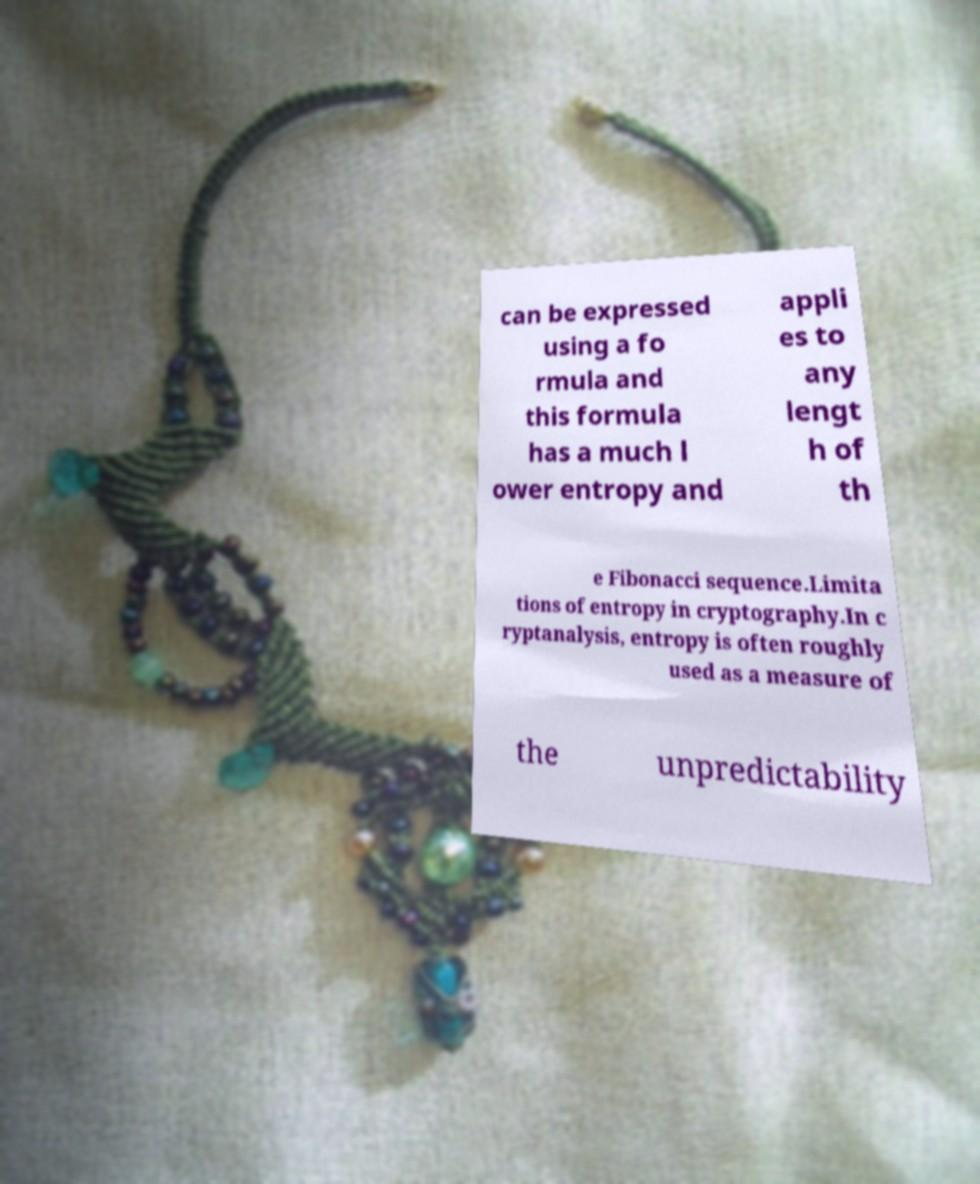Please identify and transcribe the text found in this image. can be expressed using a fo rmula and this formula has a much l ower entropy and appli es to any lengt h of th e Fibonacci sequence.Limita tions of entropy in cryptography.In c ryptanalysis, entropy is often roughly used as a measure of the unpredictability 